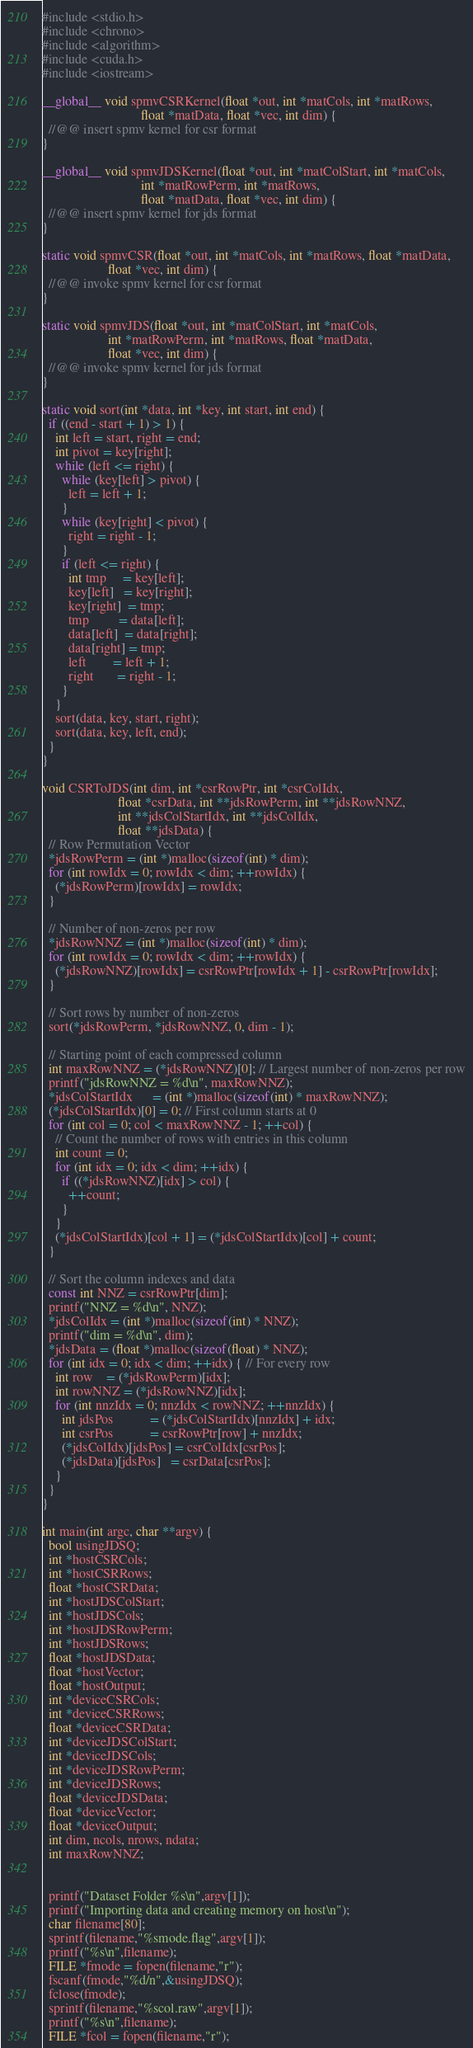Convert code to text. <code><loc_0><loc_0><loc_500><loc_500><_Cuda_>#include <stdio.h>
#include <chrono>
#include <algorithm>
#include <cuda.h>
#include <iostream>

__global__ void spmvCSRKernel(float *out, int *matCols, int *matRows,
                              float *matData, float *vec, int dim) {
  //@@ insert spmv kernel for csr format
}

__global__ void spmvJDSKernel(float *out, int *matColStart, int *matCols,
                              int *matRowPerm, int *matRows,
                              float *matData, float *vec, int dim) {
  //@@ insert spmv kernel for jds format
}

static void spmvCSR(float *out, int *matCols, int *matRows, float *matData,
                    float *vec, int dim) {
  //@@ invoke spmv kernel for csr format
}

static void spmvJDS(float *out, int *matColStart, int *matCols,
                    int *matRowPerm, int *matRows, float *matData,
                    float *vec, int dim) {
  //@@ invoke spmv kernel for jds format
}

static void sort(int *data, int *key, int start, int end) {
  if ((end - start + 1) > 1) {
    int left = start, right = end;
    int pivot = key[right];
    while (left <= right) {
      while (key[left] > pivot) {
        left = left + 1;
      }
      while (key[right] < pivot) {
        right = right - 1;
      }
      if (left <= right) {
        int tmp     = key[left];
        key[left]   = key[right];
        key[right]  = tmp;
        tmp         = data[left];
        data[left]  = data[right];
        data[right] = tmp;
        left        = left + 1;
        right       = right - 1;
      }
    }
    sort(data, key, start, right);
    sort(data, key, left, end);
  }
}

void CSRToJDS(int dim, int *csrRowPtr, int *csrColIdx,
                       float *csrData, int **jdsRowPerm, int **jdsRowNNZ,
                       int **jdsColStartIdx, int **jdsColIdx,
                       float **jdsData) {
  // Row Permutation Vector
  *jdsRowPerm = (int *)malloc(sizeof(int) * dim);
  for (int rowIdx = 0; rowIdx < dim; ++rowIdx) {
    (*jdsRowPerm)[rowIdx] = rowIdx;
  }

  // Number of non-zeros per row
  *jdsRowNNZ = (int *)malloc(sizeof(int) * dim);
  for (int rowIdx = 0; rowIdx < dim; ++rowIdx) {
    (*jdsRowNNZ)[rowIdx] = csrRowPtr[rowIdx + 1] - csrRowPtr[rowIdx];
  }

  // Sort rows by number of non-zeros
  sort(*jdsRowPerm, *jdsRowNNZ, 0, dim - 1);

  // Starting point of each compressed column
  int maxRowNNZ = (*jdsRowNNZ)[0]; // Largest number of non-zeros per row
  printf("jdsRowNNZ = %d\n", maxRowNNZ);
  *jdsColStartIdx      = (int *)malloc(sizeof(int) * maxRowNNZ);
  (*jdsColStartIdx)[0] = 0; // First column starts at 0
  for (int col = 0; col < maxRowNNZ - 1; ++col) {
    // Count the number of rows with entries in this column
    int count = 0;
    for (int idx = 0; idx < dim; ++idx) {
      if ((*jdsRowNNZ)[idx] > col) {
        ++count;
      }
    }
    (*jdsColStartIdx)[col + 1] = (*jdsColStartIdx)[col] + count;
  }

  // Sort the column indexes and data
  const int NNZ = csrRowPtr[dim];
  printf("NNZ = %d\n", NNZ);
  *jdsColIdx = (int *)malloc(sizeof(int) * NNZ);
  printf("dim = %d\n", dim);
  *jdsData = (float *)malloc(sizeof(float) * NNZ);
  for (int idx = 0; idx < dim; ++idx) { // For every row
    int row    = (*jdsRowPerm)[idx];
    int rowNNZ = (*jdsRowNNZ)[idx];
    for (int nnzIdx = 0; nnzIdx < rowNNZ; ++nnzIdx) {
      int jdsPos           = (*jdsColStartIdx)[nnzIdx] + idx;
      int csrPos           = csrRowPtr[row] + nnzIdx;
      (*jdsColIdx)[jdsPos] = csrColIdx[csrPos];
      (*jdsData)[jdsPos]   = csrData[csrPos];
    }
  }
}

int main(int argc, char **argv) {
  bool usingJDSQ;
  int *hostCSRCols;
  int *hostCSRRows;
  float *hostCSRData;
  int *hostJDSColStart;
  int *hostJDSCols;
  int *hostJDSRowPerm;
  int *hostJDSRows;
  float *hostJDSData;
  float *hostVector;
  float *hostOutput;
  int *deviceCSRCols;
  int *deviceCSRRows;
  float *deviceCSRData;
  int *deviceJDSColStart;
  int *deviceJDSCols;
  int *deviceJDSRowPerm;
  int *deviceJDSRows;
  float *deviceJDSData;
  float *deviceVector;
  float *deviceOutput;
  int dim, ncols, nrows, ndata;
  int maxRowNNZ;


  printf("Dataset Folder %s\n",argv[1]);
  printf("Importing data and creating memory on host\n");
  char filename[80];
  sprintf(filename,"%smode.flag",argv[1]);
  printf("%s\n",filename);
  FILE *fmode = fopen(filename,"r");
  fscanf(fmode,"%d/n",&usingJDSQ);
  fclose(fmode);
  sprintf(filename,"%scol.raw",argv[1]);
  printf("%s\n",filename);
  FILE *fcol = fopen(filename,"r");</code> 